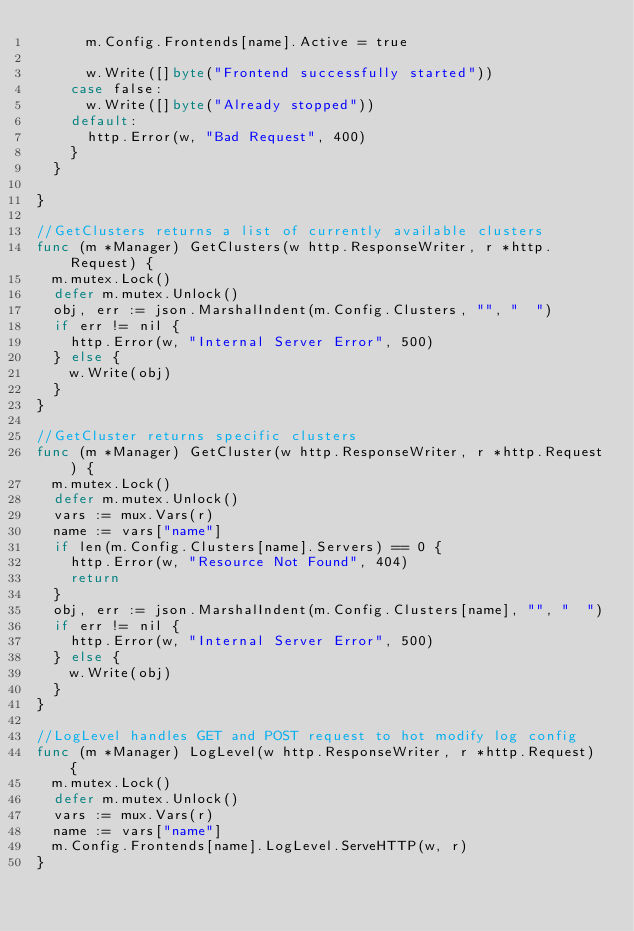Convert code to text. <code><loc_0><loc_0><loc_500><loc_500><_Go_>			m.Config.Frontends[name].Active = true

			w.Write([]byte("Frontend successfully started"))
		case false:
			w.Write([]byte("Already stopped"))
		default:
			http.Error(w, "Bad Request", 400)
		}
	}

}

//GetClusters returns a list of currently available clusters
func (m *Manager) GetClusters(w http.ResponseWriter, r *http.Request) {
	m.mutex.Lock()
	defer m.mutex.Unlock()
	obj, err := json.MarshalIndent(m.Config.Clusters, "", "  ")
	if err != nil {
		http.Error(w, "Internal Server Error", 500)
	} else {
		w.Write(obj)
	}
}

//GetCluster returns specific clusters
func (m *Manager) GetCluster(w http.ResponseWriter, r *http.Request) {
	m.mutex.Lock()
	defer m.mutex.Unlock()
	vars := mux.Vars(r)
	name := vars["name"]
	if len(m.Config.Clusters[name].Servers) == 0 {
		http.Error(w, "Resource Not Found", 404)
		return
	}
	obj, err := json.MarshalIndent(m.Config.Clusters[name], "", "  ")
	if err != nil {
		http.Error(w, "Internal Server Error", 500)
	} else {
		w.Write(obj)
	}
}

//LogLevel handles GET and POST request to hot modify log config
func (m *Manager) LogLevel(w http.ResponseWriter, r *http.Request) {
	m.mutex.Lock()
	defer m.mutex.Unlock()
	vars := mux.Vars(r)
	name := vars["name"]
	m.Config.Frontends[name].LogLevel.ServeHTTP(w, r)
}
</code> 